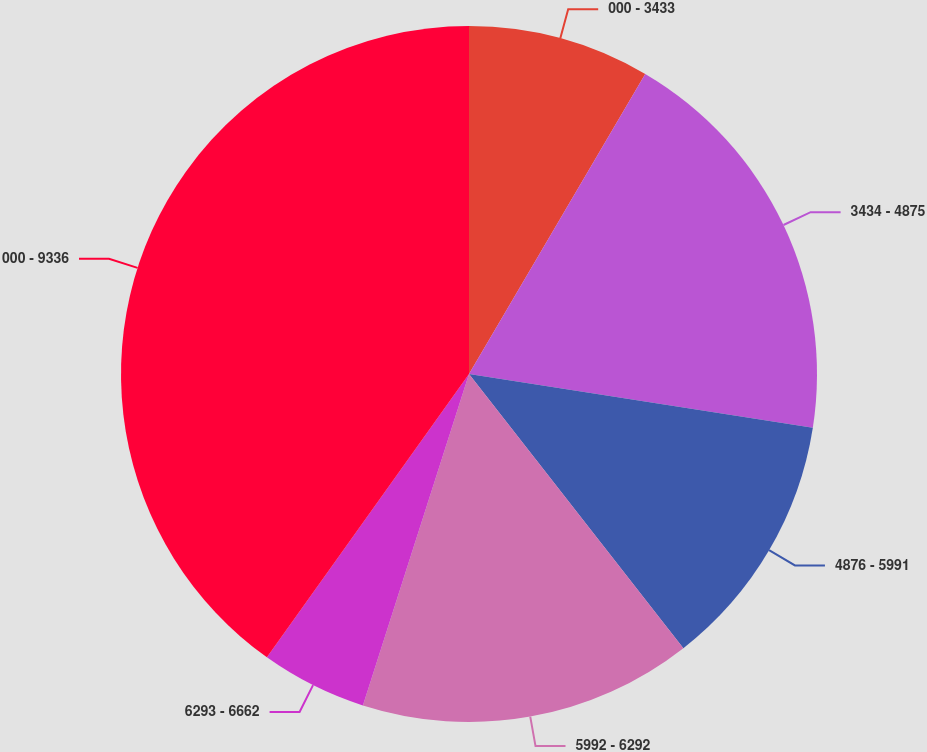Convert chart. <chart><loc_0><loc_0><loc_500><loc_500><pie_chart><fcel>000 - 3433<fcel>3434 - 4875<fcel>4876 - 5991<fcel>5992 - 6292<fcel>6293 - 6662<fcel>000 - 9336<nl><fcel>8.45%<fcel>19.01%<fcel>11.97%<fcel>15.49%<fcel>4.93%<fcel>40.13%<nl></chart> 